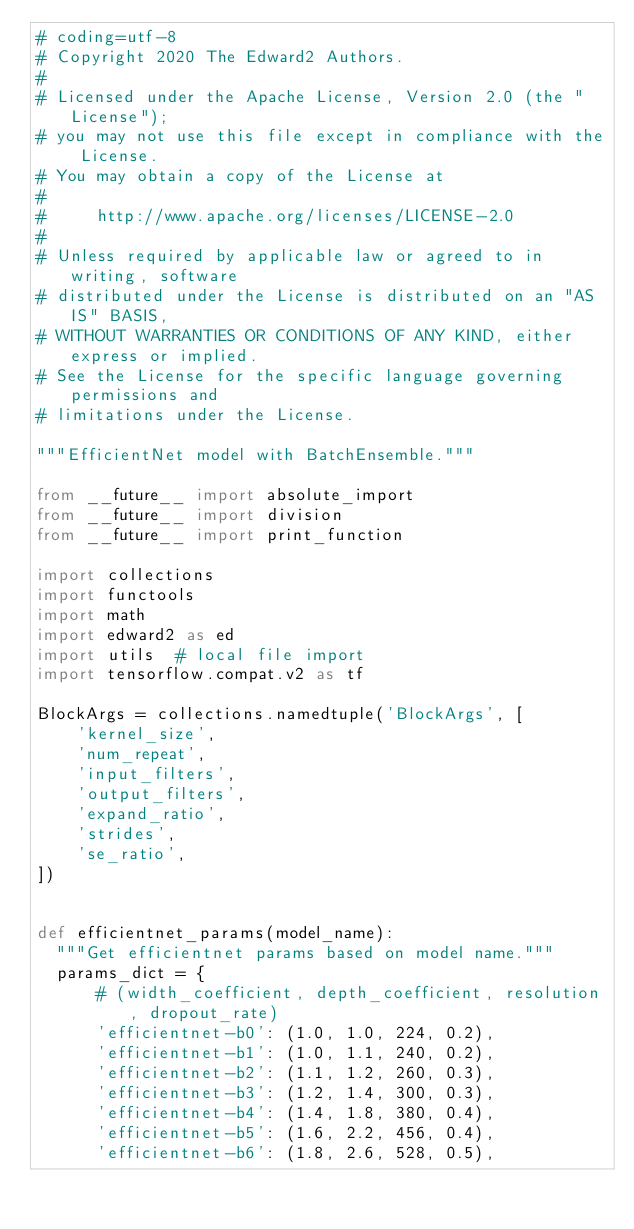<code> <loc_0><loc_0><loc_500><loc_500><_Python_># coding=utf-8
# Copyright 2020 The Edward2 Authors.
#
# Licensed under the Apache License, Version 2.0 (the "License");
# you may not use this file except in compliance with the License.
# You may obtain a copy of the License at
#
#     http://www.apache.org/licenses/LICENSE-2.0
#
# Unless required by applicable law or agreed to in writing, software
# distributed under the License is distributed on an "AS IS" BASIS,
# WITHOUT WARRANTIES OR CONDITIONS OF ANY KIND, either express or implied.
# See the License for the specific language governing permissions and
# limitations under the License.

"""EfficientNet model with BatchEnsemble."""

from __future__ import absolute_import
from __future__ import division
from __future__ import print_function

import collections
import functools
import math
import edward2 as ed
import utils  # local file import
import tensorflow.compat.v2 as tf

BlockArgs = collections.namedtuple('BlockArgs', [
    'kernel_size',
    'num_repeat',
    'input_filters',
    'output_filters',
    'expand_ratio',
    'strides',
    'se_ratio',
])


def efficientnet_params(model_name):
  """Get efficientnet params based on model name."""
  params_dict = {
      # (width_coefficient, depth_coefficient, resolution, dropout_rate)
      'efficientnet-b0': (1.0, 1.0, 224, 0.2),
      'efficientnet-b1': (1.0, 1.1, 240, 0.2),
      'efficientnet-b2': (1.1, 1.2, 260, 0.3),
      'efficientnet-b3': (1.2, 1.4, 300, 0.3),
      'efficientnet-b4': (1.4, 1.8, 380, 0.4),
      'efficientnet-b5': (1.6, 2.2, 456, 0.4),
      'efficientnet-b6': (1.8, 2.6, 528, 0.5),</code> 